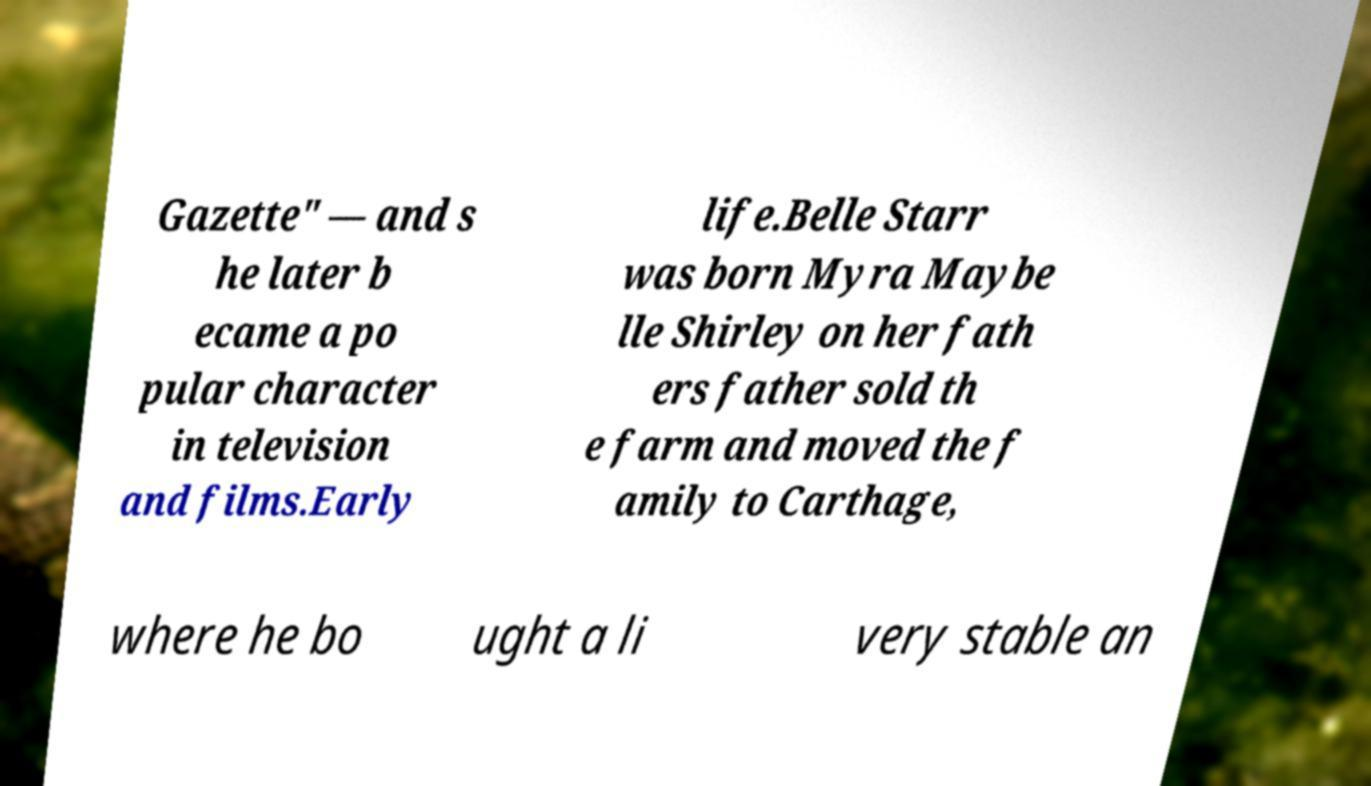Please identify and transcribe the text found in this image. Gazette" — and s he later b ecame a po pular character in television and films.Early life.Belle Starr was born Myra Maybe lle Shirley on her fath ers father sold th e farm and moved the f amily to Carthage, where he bo ught a li very stable an 